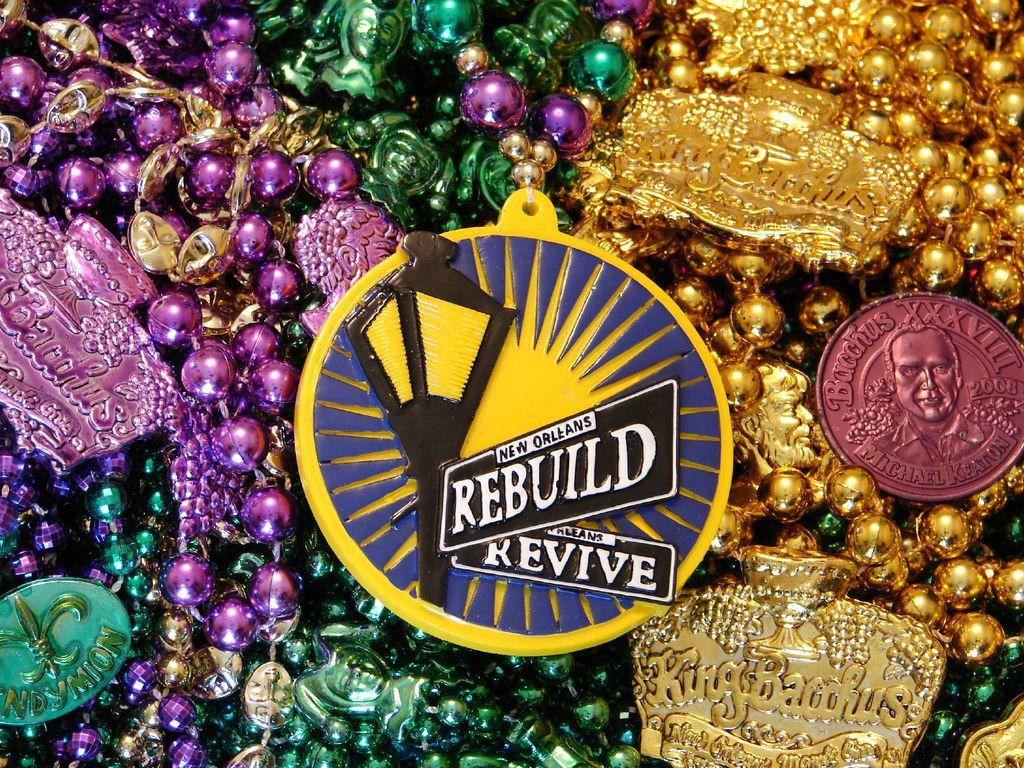What can be observed about the appearance of the items in the image? There are colorful things in the image. Are there any words or letters on any of the items? Yes, there is writing on some of the colorful things. How many frogs can be seen in the image? There are no frogs present in the image. What is the texture of the thread in the image? There is no thread present in the image. 